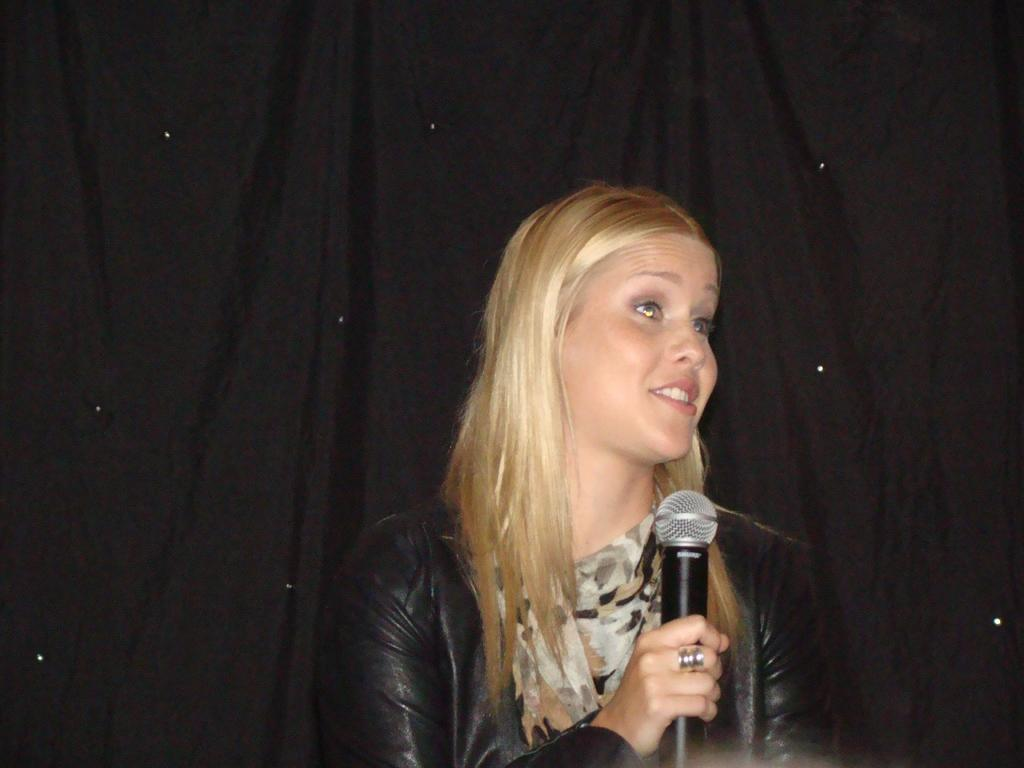Who is the main subject in the image? There is a lady in the image. What is the lady holding in the image? The lady is holding a mic. Can you describe the background of the image? There is a black cloth in the background of the image. What type of rat can be seen playing with a marble in the image? There is no rat or marble present in the image; it features a lady holding a mic. What is the sound of the thunder like in the image? There is no thunder present in the image. 